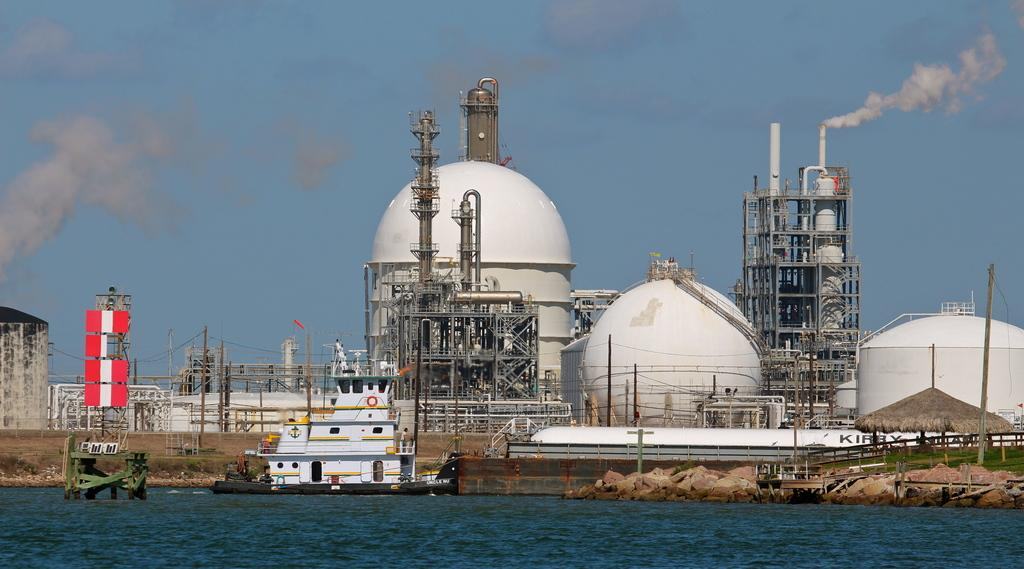What type of location is depicted in the image? The image appears to depict a factory. What can be seen on the path near the factory? There are poles with cables on the path. Is there any additional structure visible in the image? Yes, there is a hut in the image. What can be seen coming from the factory? Smoke is visible behind the factory. What is visible in the background of the image? The sky is visible in the image. What is present on the water in front of the factory? There are objects on the water in front of the factory. Can you see the tail of the animal that is about to crush the hut in the image? There is no animal present in the image, nor is there any indication of an impending crush on the hut. 